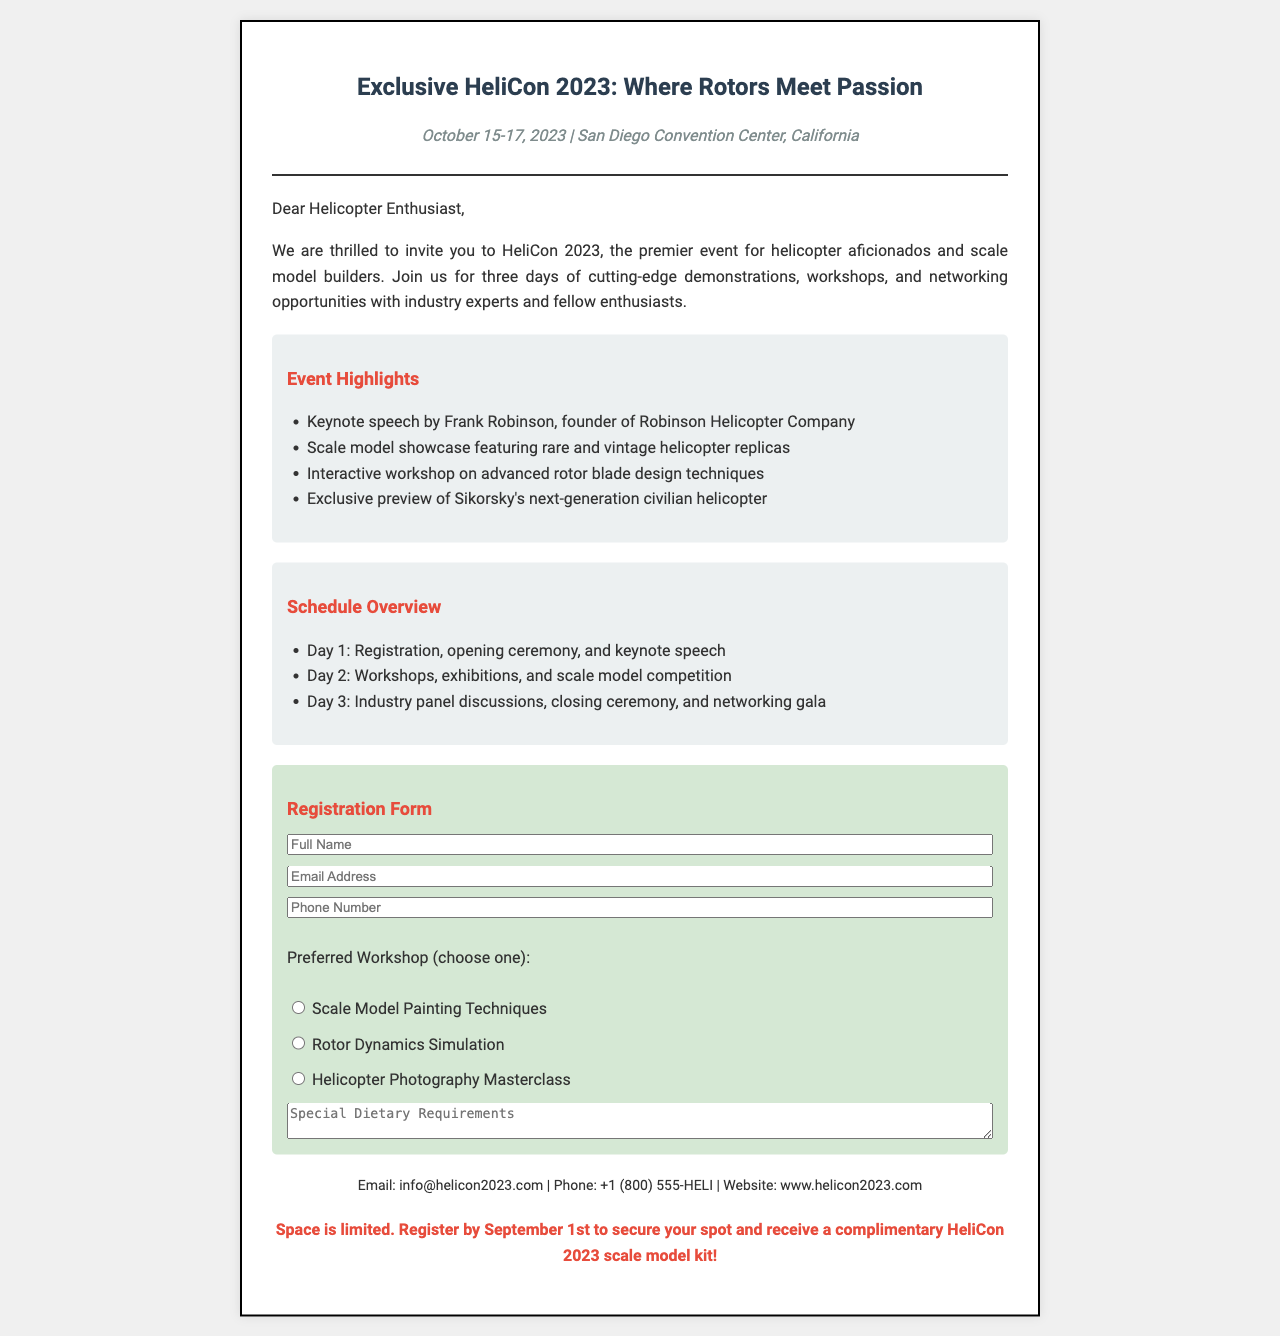What are the event dates? The dates of HeliCon 2023 are mentioned at the top of the document as October 15-17, 2023.
Answer: October 15-17, 2023 Where is the convention located? The location of the HeliCon 2023 event is indicated in the document as San Diego Convention Center, California.
Answer: San Diego Convention Center, California Who is the keynote speaker? The document specifies Frank Robinson as the keynote speaker, the founder of Robinson Helicopter Company.
Answer: Frank Robinson How many days will the event last? The document outlines the event duration over three days from October 15 to October 17.
Answer: Three days What is a registration requirement? The document states that registration must be completed by September 1st to secure a spot.
Answer: September 1st What is offered to those who register early? The document mentions that early registrants will receive a complimentary scale model kit.
Answer: Complimentary HeliCon 2023 scale model kit What is one of the workshop options? The document lists “Scale Model Painting Techniques” as one of the preferred workshop options for attendees.
Answer: Scale Model Painting Techniques How many days are dedicated to workshops? The schedule indicates that Day 2 is reserved for workshops, among other activities.
Answer: One day What type of event is HeliCon 2023? The document describes HeliCon 2023 as a premier event for helicopter aficionados and scale model builders.
Answer: Helicopter convention 